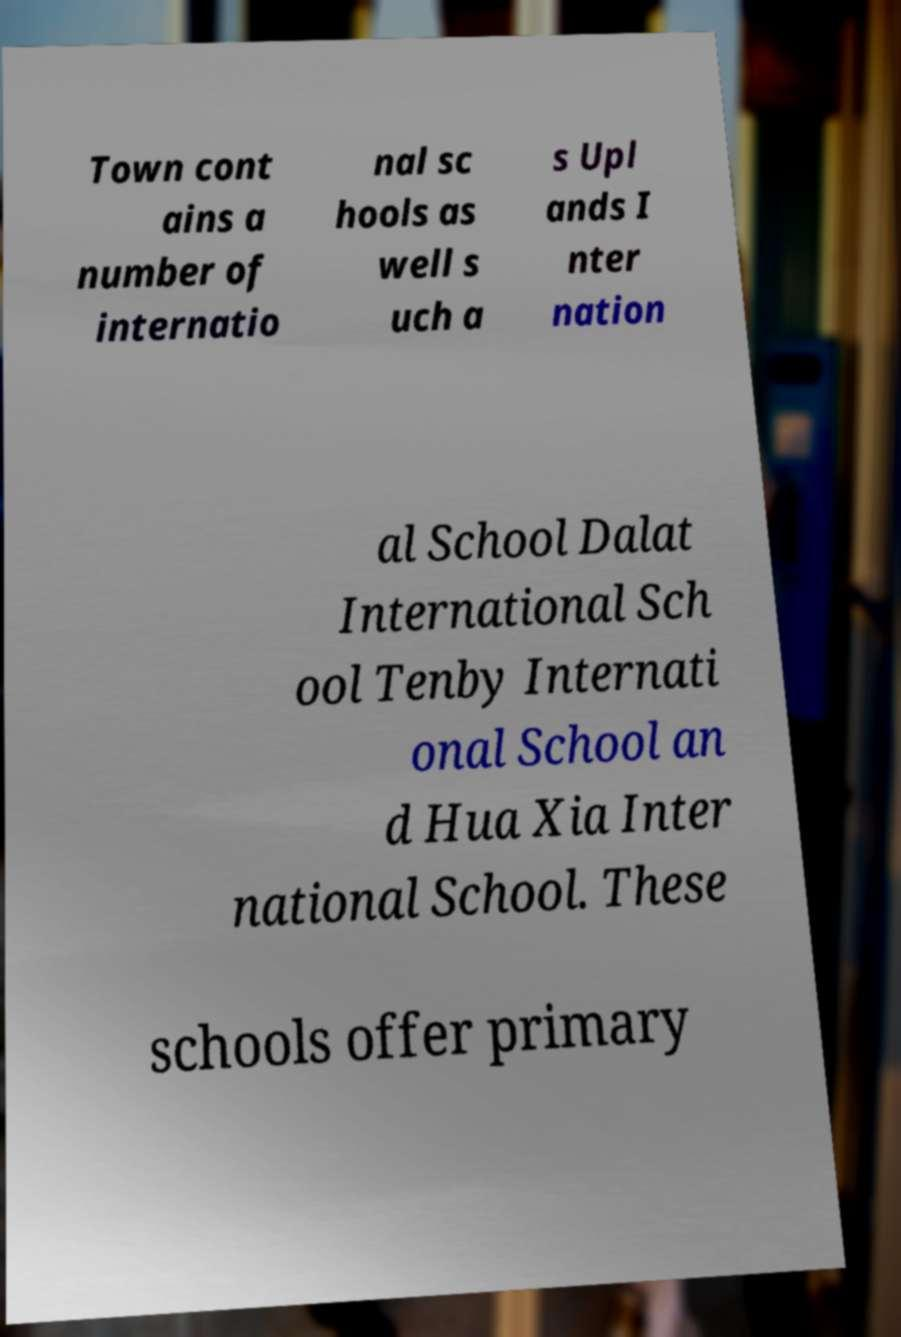Could you assist in decoding the text presented in this image and type it out clearly? Town cont ains a number of internatio nal sc hools as well s uch a s Upl ands I nter nation al School Dalat International Sch ool Tenby Internati onal School an d Hua Xia Inter national School. These schools offer primary 